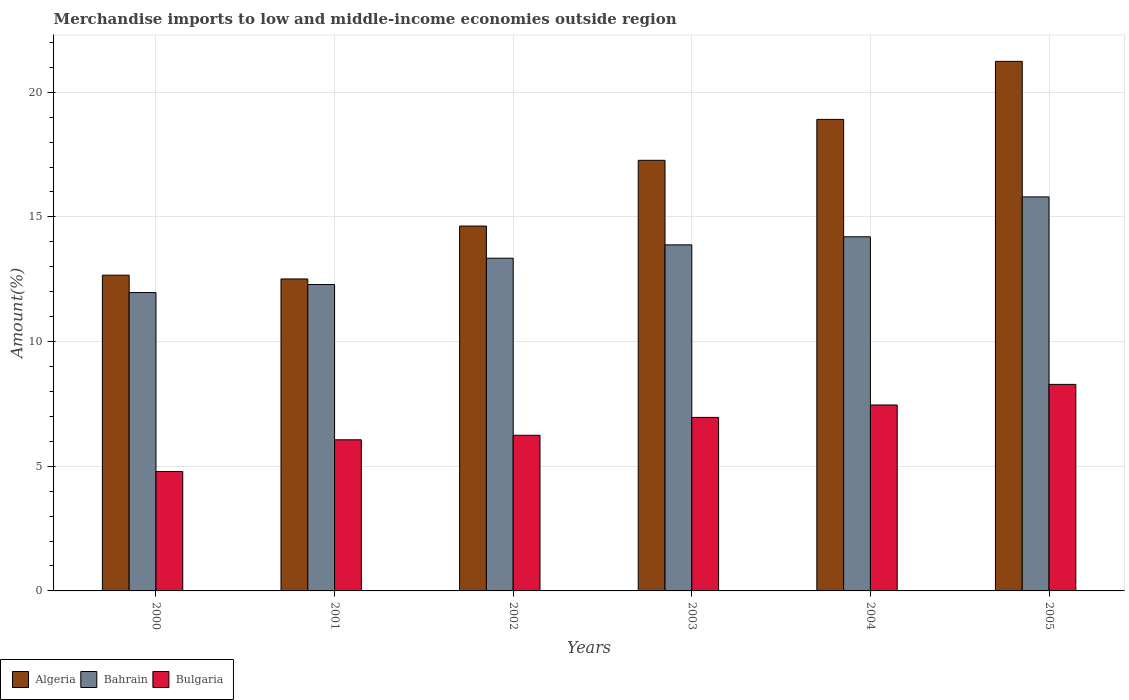How many different coloured bars are there?
Make the answer very short. 3. How many groups of bars are there?
Offer a very short reply. 6. Are the number of bars on each tick of the X-axis equal?
Keep it short and to the point. Yes. What is the label of the 5th group of bars from the left?
Ensure brevity in your answer.  2004. In how many cases, is the number of bars for a given year not equal to the number of legend labels?
Ensure brevity in your answer.  0. What is the percentage of amount earned from merchandise imports in Bahrain in 2001?
Ensure brevity in your answer.  12.29. Across all years, what is the maximum percentage of amount earned from merchandise imports in Bahrain?
Your response must be concise. 15.8. Across all years, what is the minimum percentage of amount earned from merchandise imports in Bahrain?
Your answer should be compact. 11.97. In which year was the percentage of amount earned from merchandise imports in Bahrain maximum?
Your response must be concise. 2005. In which year was the percentage of amount earned from merchandise imports in Bahrain minimum?
Ensure brevity in your answer.  2000. What is the total percentage of amount earned from merchandise imports in Algeria in the graph?
Provide a short and direct response. 97.23. What is the difference between the percentage of amount earned from merchandise imports in Bulgaria in 2003 and that in 2005?
Provide a short and direct response. -1.32. What is the difference between the percentage of amount earned from merchandise imports in Bulgaria in 2000 and the percentage of amount earned from merchandise imports in Algeria in 2002?
Your answer should be very brief. -9.84. What is the average percentage of amount earned from merchandise imports in Bulgaria per year?
Make the answer very short. 6.63. In the year 2002, what is the difference between the percentage of amount earned from merchandise imports in Bahrain and percentage of amount earned from merchandise imports in Algeria?
Keep it short and to the point. -1.29. In how many years, is the percentage of amount earned from merchandise imports in Algeria greater than 8 %?
Your answer should be very brief. 6. What is the ratio of the percentage of amount earned from merchandise imports in Bahrain in 2000 to that in 2004?
Ensure brevity in your answer.  0.84. Is the difference between the percentage of amount earned from merchandise imports in Bahrain in 2002 and 2004 greater than the difference between the percentage of amount earned from merchandise imports in Algeria in 2002 and 2004?
Provide a short and direct response. Yes. What is the difference between the highest and the second highest percentage of amount earned from merchandise imports in Bahrain?
Give a very brief answer. 1.6. What is the difference between the highest and the lowest percentage of amount earned from merchandise imports in Algeria?
Provide a succinct answer. 8.73. In how many years, is the percentage of amount earned from merchandise imports in Algeria greater than the average percentage of amount earned from merchandise imports in Algeria taken over all years?
Offer a terse response. 3. What does the 3rd bar from the left in 2002 represents?
Keep it short and to the point. Bulgaria. What does the 2nd bar from the right in 2002 represents?
Offer a very short reply. Bahrain. How many bars are there?
Keep it short and to the point. 18. Are all the bars in the graph horizontal?
Your answer should be compact. No. What is the difference between two consecutive major ticks on the Y-axis?
Give a very brief answer. 5. Does the graph contain any zero values?
Your answer should be compact. No. How many legend labels are there?
Your answer should be compact. 3. What is the title of the graph?
Offer a terse response. Merchandise imports to low and middle-income economies outside region. What is the label or title of the Y-axis?
Your answer should be compact. Amount(%). What is the Amount(%) of Algeria in 2000?
Keep it short and to the point. 12.66. What is the Amount(%) in Bahrain in 2000?
Give a very brief answer. 11.97. What is the Amount(%) in Bulgaria in 2000?
Offer a very short reply. 4.79. What is the Amount(%) in Algeria in 2001?
Offer a very short reply. 12.51. What is the Amount(%) of Bahrain in 2001?
Make the answer very short. 12.29. What is the Amount(%) of Bulgaria in 2001?
Provide a short and direct response. 6.06. What is the Amount(%) of Algeria in 2002?
Offer a very short reply. 14.63. What is the Amount(%) in Bahrain in 2002?
Give a very brief answer. 13.34. What is the Amount(%) in Bulgaria in 2002?
Make the answer very short. 6.24. What is the Amount(%) of Algeria in 2003?
Your response must be concise. 17.27. What is the Amount(%) of Bahrain in 2003?
Keep it short and to the point. 13.88. What is the Amount(%) of Bulgaria in 2003?
Offer a very short reply. 6.96. What is the Amount(%) in Algeria in 2004?
Provide a short and direct response. 18.91. What is the Amount(%) in Bahrain in 2004?
Give a very brief answer. 14.2. What is the Amount(%) of Bulgaria in 2004?
Your response must be concise. 7.46. What is the Amount(%) in Algeria in 2005?
Ensure brevity in your answer.  21.24. What is the Amount(%) in Bahrain in 2005?
Make the answer very short. 15.8. What is the Amount(%) in Bulgaria in 2005?
Your answer should be compact. 8.28. Across all years, what is the maximum Amount(%) in Algeria?
Your answer should be compact. 21.24. Across all years, what is the maximum Amount(%) of Bahrain?
Provide a succinct answer. 15.8. Across all years, what is the maximum Amount(%) of Bulgaria?
Ensure brevity in your answer.  8.28. Across all years, what is the minimum Amount(%) in Algeria?
Offer a very short reply. 12.51. Across all years, what is the minimum Amount(%) of Bahrain?
Your response must be concise. 11.97. Across all years, what is the minimum Amount(%) in Bulgaria?
Keep it short and to the point. 4.79. What is the total Amount(%) in Algeria in the graph?
Provide a short and direct response. 97.22. What is the total Amount(%) of Bahrain in the graph?
Offer a very short reply. 81.48. What is the total Amount(%) in Bulgaria in the graph?
Your answer should be very brief. 39.79. What is the difference between the Amount(%) in Algeria in 2000 and that in 2001?
Make the answer very short. 0.15. What is the difference between the Amount(%) of Bahrain in 2000 and that in 2001?
Offer a terse response. -0.32. What is the difference between the Amount(%) in Bulgaria in 2000 and that in 2001?
Keep it short and to the point. -1.27. What is the difference between the Amount(%) in Algeria in 2000 and that in 2002?
Offer a terse response. -1.97. What is the difference between the Amount(%) of Bahrain in 2000 and that in 2002?
Offer a terse response. -1.38. What is the difference between the Amount(%) of Bulgaria in 2000 and that in 2002?
Your answer should be compact. -1.45. What is the difference between the Amount(%) of Algeria in 2000 and that in 2003?
Your answer should be compact. -4.6. What is the difference between the Amount(%) of Bahrain in 2000 and that in 2003?
Ensure brevity in your answer.  -1.91. What is the difference between the Amount(%) in Bulgaria in 2000 and that in 2003?
Your response must be concise. -2.17. What is the difference between the Amount(%) in Algeria in 2000 and that in 2004?
Keep it short and to the point. -6.25. What is the difference between the Amount(%) in Bahrain in 2000 and that in 2004?
Give a very brief answer. -2.24. What is the difference between the Amount(%) of Bulgaria in 2000 and that in 2004?
Your answer should be very brief. -2.67. What is the difference between the Amount(%) in Algeria in 2000 and that in 2005?
Provide a short and direct response. -8.57. What is the difference between the Amount(%) in Bahrain in 2000 and that in 2005?
Give a very brief answer. -3.84. What is the difference between the Amount(%) in Bulgaria in 2000 and that in 2005?
Keep it short and to the point. -3.49. What is the difference between the Amount(%) of Algeria in 2001 and that in 2002?
Your answer should be compact. -2.12. What is the difference between the Amount(%) of Bahrain in 2001 and that in 2002?
Provide a short and direct response. -1.05. What is the difference between the Amount(%) of Bulgaria in 2001 and that in 2002?
Your answer should be compact. -0.18. What is the difference between the Amount(%) in Algeria in 2001 and that in 2003?
Offer a terse response. -4.76. What is the difference between the Amount(%) of Bahrain in 2001 and that in 2003?
Your answer should be compact. -1.59. What is the difference between the Amount(%) of Bulgaria in 2001 and that in 2003?
Provide a short and direct response. -0.9. What is the difference between the Amount(%) in Algeria in 2001 and that in 2004?
Provide a succinct answer. -6.4. What is the difference between the Amount(%) in Bahrain in 2001 and that in 2004?
Your response must be concise. -1.91. What is the difference between the Amount(%) of Bulgaria in 2001 and that in 2004?
Your answer should be compact. -1.4. What is the difference between the Amount(%) of Algeria in 2001 and that in 2005?
Provide a succinct answer. -8.73. What is the difference between the Amount(%) of Bahrain in 2001 and that in 2005?
Make the answer very short. -3.51. What is the difference between the Amount(%) in Bulgaria in 2001 and that in 2005?
Keep it short and to the point. -2.22. What is the difference between the Amount(%) of Algeria in 2002 and that in 2003?
Offer a terse response. -2.64. What is the difference between the Amount(%) in Bahrain in 2002 and that in 2003?
Offer a terse response. -0.54. What is the difference between the Amount(%) in Bulgaria in 2002 and that in 2003?
Offer a very short reply. -0.72. What is the difference between the Amount(%) of Algeria in 2002 and that in 2004?
Give a very brief answer. -4.28. What is the difference between the Amount(%) in Bahrain in 2002 and that in 2004?
Your response must be concise. -0.86. What is the difference between the Amount(%) in Bulgaria in 2002 and that in 2004?
Offer a terse response. -1.22. What is the difference between the Amount(%) of Algeria in 2002 and that in 2005?
Offer a very short reply. -6.6. What is the difference between the Amount(%) of Bahrain in 2002 and that in 2005?
Provide a succinct answer. -2.46. What is the difference between the Amount(%) in Bulgaria in 2002 and that in 2005?
Ensure brevity in your answer.  -2.04. What is the difference between the Amount(%) in Algeria in 2003 and that in 2004?
Provide a short and direct response. -1.64. What is the difference between the Amount(%) of Bahrain in 2003 and that in 2004?
Make the answer very short. -0.32. What is the difference between the Amount(%) of Bulgaria in 2003 and that in 2004?
Keep it short and to the point. -0.5. What is the difference between the Amount(%) of Algeria in 2003 and that in 2005?
Your answer should be compact. -3.97. What is the difference between the Amount(%) of Bahrain in 2003 and that in 2005?
Provide a short and direct response. -1.92. What is the difference between the Amount(%) of Bulgaria in 2003 and that in 2005?
Provide a short and direct response. -1.32. What is the difference between the Amount(%) in Algeria in 2004 and that in 2005?
Your answer should be compact. -2.33. What is the difference between the Amount(%) of Bahrain in 2004 and that in 2005?
Your response must be concise. -1.6. What is the difference between the Amount(%) of Bulgaria in 2004 and that in 2005?
Give a very brief answer. -0.83. What is the difference between the Amount(%) of Algeria in 2000 and the Amount(%) of Bahrain in 2001?
Offer a terse response. 0.38. What is the difference between the Amount(%) of Algeria in 2000 and the Amount(%) of Bulgaria in 2001?
Your response must be concise. 6.6. What is the difference between the Amount(%) in Bahrain in 2000 and the Amount(%) in Bulgaria in 2001?
Ensure brevity in your answer.  5.9. What is the difference between the Amount(%) of Algeria in 2000 and the Amount(%) of Bahrain in 2002?
Ensure brevity in your answer.  -0.68. What is the difference between the Amount(%) of Algeria in 2000 and the Amount(%) of Bulgaria in 2002?
Your answer should be compact. 6.42. What is the difference between the Amount(%) of Bahrain in 2000 and the Amount(%) of Bulgaria in 2002?
Offer a very short reply. 5.72. What is the difference between the Amount(%) in Algeria in 2000 and the Amount(%) in Bahrain in 2003?
Offer a terse response. -1.21. What is the difference between the Amount(%) of Algeria in 2000 and the Amount(%) of Bulgaria in 2003?
Your answer should be compact. 5.7. What is the difference between the Amount(%) of Bahrain in 2000 and the Amount(%) of Bulgaria in 2003?
Offer a very short reply. 5.01. What is the difference between the Amount(%) of Algeria in 2000 and the Amount(%) of Bahrain in 2004?
Give a very brief answer. -1.54. What is the difference between the Amount(%) in Algeria in 2000 and the Amount(%) in Bulgaria in 2004?
Give a very brief answer. 5.21. What is the difference between the Amount(%) of Bahrain in 2000 and the Amount(%) of Bulgaria in 2004?
Offer a terse response. 4.51. What is the difference between the Amount(%) in Algeria in 2000 and the Amount(%) in Bahrain in 2005?
Offer a very short reply. -3.14. What is the difference between the Amount(%) in Algeria in 2000 and the Amount(%) in Bulgaria in 2005?
Your response must be concise. 4.38. What is the difference between the Amount(%) in Bahrain in 2000 and the Amount(%) in Bulgaria in 2005?
Your response must be concise. 3.68. What is the difference between the Amount(%) of Algeria in 2001 and the Amount(%) of Bahrain in 2002?
Your answer should be compact. -0.83. What is the difference between the Amount(%) in Algeria in 2001 and the Amount(%) in Bulgaria in 2002?
Give a very brief answer. 6.27. What is the difference between the Amount(%) of Bahrain in 2001 and the Amount(%) of Bulgaria in 2002?
Ensure brevity in your answer.  6.05. What is the difference between the Amount(%) in Algeria in 2001 and the Amount(%) in Bahrain in 2003?
Your response must be concise. -1.37. What is the difference between the Amount(%) of Algeria in 2001 and the Amount(%) of Bulgaria in 2003?
Ensure brevity in your answer.  5.55. What is the difference between the Amount(%) in Bahrain in 2001 and the Amount(%) in Bulgaria in 2003?
Keep it short and to the point. 5.33. What is the difference between the Amount(%) in Algeria in 2001 and the Amount(%) in Bahrain in 2004?
Your answer should be compact. -1.69. What is the difference between the Amount(%) of Algeria in 2001 and the Amount(%) of Bulgaria in 2004?
Your response must be concise. 5.05. What is the difference between the Amount(%) in Bahrain in 2001 and the Amount(%) in Bulgaria in 2004?
Make the answer very short. 4.83. What is the difference between the Amount(%) in Algeria in 2001 and the Amount(%) in Bahrain in 2005?
Your answer should be compact. -3.29. What is the difference between the Amount(%) of Algeria in 2001 and the Amount(%) of Bulgaria in 2005?
Your answer should be compact. 4.23. What is the difference between the Amount(%) of Bahrain in 2001 and the Amount(%) of Bulgaria in 2005?
Your response must be concise. 4. What is the difference between the Amount(%) in Algeria in 2002 and the Amount(%) in Bahrain in 2003?
Offer a very short reply. 0.76. What is the difference between the Amount(%) of Algeria in 2002 and the Amount(%) of Bulgaria in 2003?
Your answer should be compact. 7.67. What is the difference between the Amount(%) of Bahrain in 2002 and the Amount(%) of Bulgaria in 2003?
Offer a terse response. 6.38. What is the difference between the Amount(%) of Algeria in 2002 and the Amount(%) of Bahrain in 2004?
Provide a short and direct response. 0.43. What is the difference between the Amount(%) in Algeria in 2002 and the Amount(%) in Bulgaria in 2004?
Provide a short and direct response. 7.18. What is the difference between the Amount(%) in Bahrain in 2002 and the Amount(%) in Bulgaria in 2004?
Make the answer very short. 5.89. What is the difference between the Amount(%) in Algeria in 2002 and the Amount(%) in Bahrain in 2005?
Make the answer very short. -1.17. What is the difference between the Amount(%) of Algeria in 2002 and the Amount(%) of Bulgaria in 2005?
Your answer should be compact. 6.35. What is the difference between the Amount(%) in Bahrain in 2002 and the Amount(%) in Bulgaria in 2005?
Provide a short and direct response. 5.06. What is the difference between the Amount(%) in Algeria in 2003 and the Amount(%) in Bahrain in 2004?
Keep it short and to the point. 3.07. What is the difference between the Amount(%) of Algeria in 2003 and the Amount(%) of Bulgaria in 2004?
Offer a very short reply. 9.81. What is the difference between the Amount(%) of Bahrain in 2003 and the Amount(%) of Bulgaria in 2004?
Make the answer very short. 6.42. What is the difference between the Amount(%) of Algeria in 2003 and the Amount(%) of Bahrain in 2005?
Your response must be concise. 1.47. What is the difference between the Amount(%) in Algeria in 2003 and the Amount(%) in Bulgaria in 2005?
Your answer should be compact. 8.99. What is the difference between the Amount(%) in Bahrain in 2003 and the Amount(%) in Bulgaria in 2005?
Keep it short and to the point. 5.59. What is the difference between the Amount(%) of Algeria in 2004 and the Amount(%) of Bahrain in 2005?
Your response must be concise. 3.11. What is the difference between the Amount(%) in Algeria in 2004 and the Amount(%) in Bulgaria in 2005?
Give a very brief answer. 10.63. What is the difference between the Amount(%) of Bahrain in 2004 and the Amount(%) of Bulgaria in 2005?
Provide a succinct answer. 5.92. What is the average Amount(%) in Algeria per year?
Provide a succinct answer. 16.2. What is the average Amount(%) of Bahrain per year?
Offer a very short reply. 13.58. What is the average Amount(%) in Bulgaria per year?
Ensure brevity in your answer.  6.63. In the year 2000, what is the difference between the Amount(%) in Algeria and Amount(%) in Bahrain?
Offer a terse response. 0.7. In the year 2000, what is the difference between the Amount(%) in Algeria and Amount(%) in Bulgaria?
Your answer should be very brief. 7.87. In the year 2000, what is the difference between the Amount(%) in Bahrain and Amount(%) in Bulgaria?
Your answer should be very brief. 7.18. In the year 2001, what is the difference between the Amount(%) in Algeria and Amount(%) in Bahrain?
Keep it short and to the point. 0.22. In the year 2001, what is the difference between the Amount(%) in Algeria and Amount(%) in Bulgaria?
Your answer should be very brief. 6.45. In the year 2001, what is the difference between the Amount(%) in Bahrain and Amount(%) in Bulgaria?
Keep it short and to the point. 6.23. In the year 2002, what is the difference between the Amount(%) in Algeria and Amount(%) in Bahrain?
Offer a terse response. 1.29. In the year 2002, what is the difference between the Amount(%) of Algeria and Amount(%) of Bulgaria?
Your answer should be very brief. 8.39. In the year 2002, what is the difference between the Amount(%) in Bahrain and Amount(%) in Bulgaria?
Ensure brevity in your answer.  7.1. In the year 2003, what is the difference between the Amount(%) of Algeria and Amount(%) of Bahrain?
Provide a short and direct response. 3.39. In the year 2003, what is the difference between the Amount(%) in Algeria and Amount(%) in Bulgaria?
Your answer should be very brief. 10.31. In the year 2003, what is the difference between the Amount(%) in Bahrain and Amount(%) in Bulgaria?
Offer a very short reply. 6.92. In the year 2004, what is the difference between the Amount(%) in Algeria and Amount(%) in Bahrain?
Offer a very short reply. 4.71. In the year 2004, what is the difference between the Amount(%) of Algeria and Amount(%) of Bulgaria?
Your answer should be very brief. 11.45. In the year 2004, what is the difference between the Amount(%) in Bahrain and Amount(%) in Bulgaria?
Ensure brevity in your answer.  6.75. In the year 2005, what is the difference between the Amount(%) of Algeria and Amount(%) of Bahrain?
Offer a very short reply. 5.44. In the year 2005, what is the difference between the Amount(%) of Algeria and Amount(%) of Bulgaria?
Your response must be concise. 12.95. In the year 2005, what is the difference between the Amount(%) of Bahrain and Amount(%) of Bulgaria?
Make the answer very short. 7.52. What is the ratio of the Amount(%) of Algeria in 2000 to that in 2001?
Your answer should be very brief. 1.01. What is the ratio of the Amount(%) in Bahrain in 2000 to that in 2001?
Give a very brief answer. 0.97. What is the ratio of the Amount(%) of Bulgaria in 2000 to that in 2001?
Offer a terse response. 0.79. What is the ratio of the Amount(%) in Algeria in 2000 to that in 2002?
Your response must be concise. 0.87. What is the ratio of the Amount(%) in Bahrain in 2000 to that in 2002?
Your answer should be compact. 0.9. What is the ratio of the Amount(%) of Bulgaria in 2000 to that in 2002?
Provide a short and direct response. 0.77. What is the ratio of the Amount(%) of Algeria in 2000 to that in 2003?
Keep it short and to the point. 0.73. What is the ratio of the Amount(%) of Bahrain in 2000 to that in 2003?
Provide a short and direct response. 0.86. What is the ratio of the Amount(%) of Bulgaria in 2000 to that in 2003?
Provide a succinct answer. 0.69. What is the ratio of the Amount(%) in Algeria in 2000 to that in 2004?
Make the answer very short. 0.67. What is the ratio of the Amount(%) of Bahrain in 2000 to that in 2004?
Your response must be concise. 0.84. What is the ratio of the Amount(%) in Bulgaria in 2000 to that in 2004?
Offer a very short reply. 0.64. What is the ratio of the Amount(%) in Algeria in 2000 to that in 2005?
Your response must be concise. 0.6. What is the ratio of the Amount(%) of Bahrain in 2000 to that in 2005?
Keep it short and to the point. 0.76. What is the ratio of the Amount(%) of Bulgaria in 2000 to that in 2005?
Keep it short and to the point. 0.58. What is the ratio of the Amount(%) of Algeria in 2001 to that in 2002?
Your response must be concise. 0.85. What is the ratio of the Amount(%) of Bahrain in 2001 to that in 2002?
Your response must be concise. 0.92. What is the ratio of the Amount(%) of Bulgaria in 2001 to that in 2002?
Keep it short and to the point. 0.97. What is the ratio of the Amount(%) of Algeria in 2001 to that in 2003?
Offer a very short reply. 0.72. What is the ratio of the Amount(%) of Bahrain in 2001 to that in 2003?
Provide a succinct answer. 0.89. What is the ratio of the Amount(%) in Bulgaria in 2001 to that in 2003?
Your answer should be very brief. 0.87. What is the ratio of the Amount(%) in Algeria in 2001 to that in 2004?
Make the answer very short. 0.66. What is the ratio of the Amount(%) of Bahrain in 2001 to that in 2004?
Ensure brevity in your answer.  0.87. What is the ratio of the Amount(%) of Bulgaria in 2001 to that in 2004?
Offer a terse response. 0.81. What is the ratio of the Amount(%) in Algeria in 2001 to that in 2005?
Your answer should be compact. 0.59. What is the ratio of the Amount(%) of Bahrain in 2001 to that in 2005?
Keep it short and to the point. 0.78. What is the ratio of the Amount(%) of Bulgaria in 2001 to that in 2005?
Make the answer very short. 0.73. What is the ratio of the Amount(%) of Algeria in 2002 to that in 2003?
Your answer should be compact. 0.85. What is the ratio of the Amount(%) in Bahrain in 2002 to that in 2003?
Your answer should be very brief. 0.96. What is the ratio of the Amount(%) of Bulgaria in 2002 to that in 2003?
Provide a short and direct response. 0.9. What is the ratio of the Amount(%) of Algeria in 2002 to that in 2004?
Give a very brief answer. 0.77. What is the ratio of the Amount(%) in Bahrain in 2002 to that in 2004?
Provide a succinct answer. 0.94. What is the ratio of the Amount(%) in Bulgaria in 2002 to that in 2004?
Keep it short and to the point. 0.84. What is the ratio of the Amount(%) in Algeria in 2002 to that in 2005?
Keep it short and to the point. 0.69. What is the ratio of the Amount(%) in Bahrain in 2002 to that in 2005?
Offer a very short reply. 0.84. What is the ratio of the Amount(%) of Bulgaria in 2002 to that in 2005?
Offer a terse response. 0.75. What is the ratio of the Amount(%) of Algeria in 2003 to that in 2004?
Provide a short and direct response. 0.91. What is the ratio of the Amount(%) in Bahrain in 2003 to that in 2004?
Make the answer very short. 0.98. What is the ratio of the Amount(%) of Bulgaria in 2003 to that in 2004?
Your answer should be very brief. 0.93. What is the ratio of the Amount(%) of Algeria in 2003 to that in 2005?
Ensure brevity in your answer.  0.81. What is the ratio of the Amount(%) in Bahrain in 2003 to that in 2005?
Give a very brief answer. 0.88. What is the ratio of the Amount(%) of Bulgaria in 2003 to that in 2005?
Provide a short and direct response. 0.84. What is the ratio of the Amount(%) in Algeria in 2004 to that in 2005?
Provide a short and direct response. 0.89. What is the ratio of the Amount(%) in Bahrain in 2004 to that in 2005?
Keep it short and to the point. 0.9. What is the ratio of the Amount(%) in Bulgaria in 2004 to that in 2005?
Ensure brevity in your answer.  0.9. What is the difference between the highest and the second highest Amount(%) of Algeria?
Give a very brief answer. 2.33. What is the difference between the highest and the second highest Amount(%) of Bahrain?
Provide a succinct answer. 1.6. What is the difference between the highest and the second highest Amount(%) of Bulgaria?
Provide a succinct answer. 0.83. What is the difference between the highest and the lowest Amount(%) of Algeria?
Offer a terse response. 8.73. What is the difference between the highest and the lowest Amount(%) of Bahrain?
Give a very brief answer. 3.84. What is the difference between the highest and the lowest Amount(%) of Bulgaria?
Your answer should be compact. 3.49. 